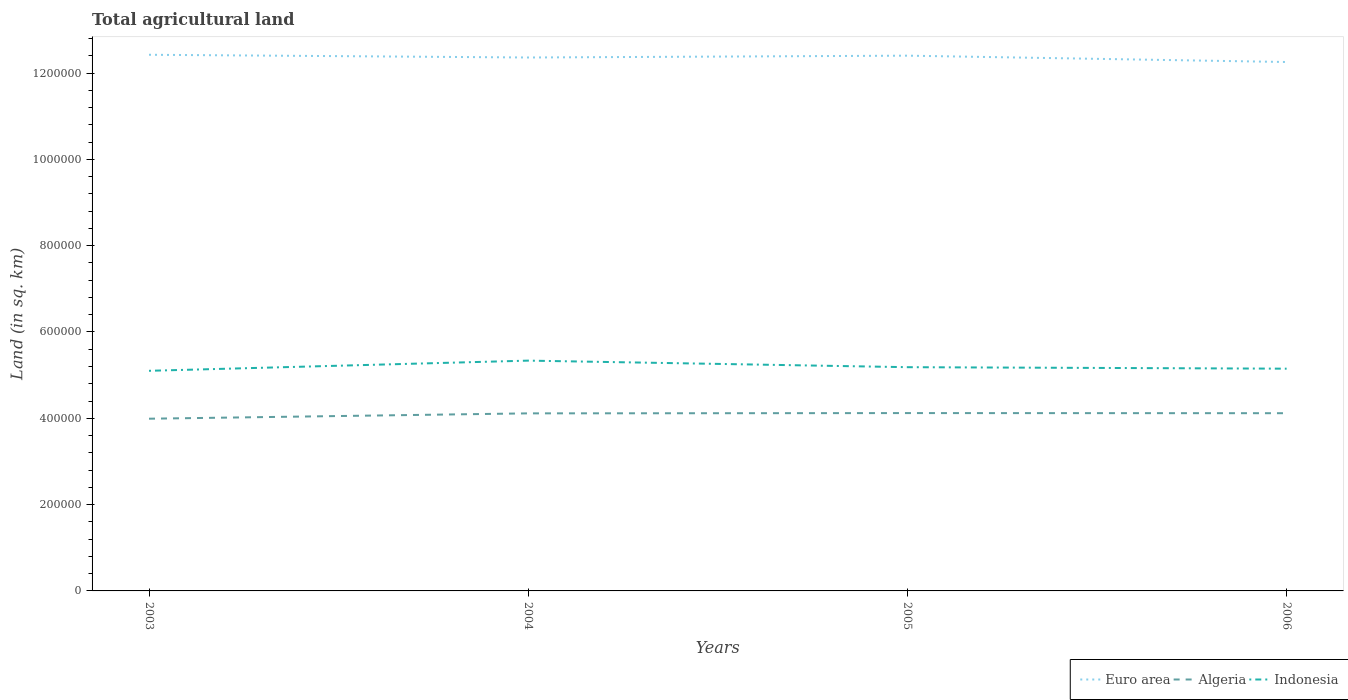Does the line corresponding to Algeria intersect with the line corresponding to Euro area?
Your answer should be very brief. No. Across all years, what is the maximum total agricultural land in Algeria?
Your response must be concise. 3.99e+05. What is the total total agricultural land in Euro area in the graph?
Provide a short and direct response. -4246.5. What is the difference between the highest and the second highest total agricultural land in Euro area?
Give a very brief answer. 1.68e+04. What is the difference between the highest and the lowest total agricultural land in Indonesia?
Offer a terse response. 1. How many years are there in the graph?
Keep it short and to the point. 4. What is the difference between two consecutive major ticks on the Y-axis?
Your answer should be compact. 2.00e+05. Does the graph contain grids?
Provide a succinct answer. No. Where does the legend appear in the graph?
Keep it short and to the point. Bottom right. What is the title of the graph?
Offer a very short reply. Total agricultural land. Does "Israel" appear as one of the legend labels in the graph?
Ensure brevity in your answer.  No. What is the label or title of the Y-axis?
Your answer should be very brief. Land (in sq. km). What is the Land (in sq. km) of Euro area in 2003?
Ensure brevity in your answer.  1.24e+06. What is the Land (in sq. km) in Algeria in 2003?
Your answer should be very brief. 3.99e+05. What is the Land (in sq. km) in Indonesia in 2003?
Provide a succinct answer. 5.10e+05. What is the Land (in sq. km) of Euro area in 2004?
Your response must be concise. 1.24e+06. What is the Land (in sq. km) of Algeria in 2004?
Your answer should be very brief. 4.11e+05. What is the Land (in sq. km) of Indonesia in 2004?
Offer a very short reply. 5.34e+05. What is the Land (in sq. km) in Euro area in 2005?
Offer a very short reply. 1.24e+06. What is the Land (in sq. km) in Algeria in 2005?
Offer a terse response. 4.12e+05. What is the Land (in sq. km) of Indonesia in 2005?
Offer a terse response. 5.18e+05. What is the Land (in sq. km) of Euro area in 2006?
Offer a very short reply. 1.23e+06. What is the Land (in sq. km) in Algeria in 2006?
Provide a succinct answer. 4.12e+05. What is the Land (in sq. km) in Indonesia in 2006?
Provide a succinct answer. 5.15e+05. Across all years, what is the maximum Land (in sq. km) in Euro area?
Provide a succinct answer. 1.24e+06. Across all years, what is the maximum Land (in sq. km) of Algeria?
Offer a terse response. 4.12e+05. Across all years, what is the maximum Land (in sq. km) in Indonesia?
Offer a very short reply. 5.34e+05. Across all years, what is the minimum Land (in sq. km) in Euro area?
Give a very brief answer. 1.23e+06. Across all years, what is the minimum Land (in sq. km) in Algeria?
Provide a succinct answer. 3.99e+05. Across all years, what is the minimum Land (in sq. km) of Indonesia?
Give a very brief answer. 5.10e+05. What is the total Land (in sq. km) in Euro area in the graph?
Provide a succinct answer. 4.94e+06. What is the total Land (in sq. km) of Algeria in the graph?
Your response must be concise. 1.63e+06. What is the total Land (in sq. km) of Indonesia in the graph?
Make the answer very short. 2.08e+06. What is the difference between the Land (in sq. km) of Euro area in 2003 and that in 2004?
Provide a short and direct response. 6314.3. What is the difference between the Land (in sq. km) in Algeria in 2003 and that in 2004?
Offer a terse response. -1.24e+04. What is the difference between the Land (in sq. km) of Indonesia in 2003 and that in 2004?
Provide a short and direct response. -2.36e+04. What is the difference between the Land (in sq. km) in Euro area in 2003 and that in 2005?
Your answer should be very brief. 2067.8. What is the difference between the Land (in sq. km) in Algeria in 2003 and that in 2005?
Provide a short and direct response. -1.31e+04. What is the difference between the Land (in sq. km) of Indonesia in 2003 and that in 2005?
Offer a terse response. -8400. What is the difference between the Land (in sq. km) in Euro area in 2003 and that in 2006?
Your answer should be compact. 1.68e+04. What is the difference between the Land (in sq. km) in Algeria in 2003 and that in 2006?
Your answer should be very brief. -1.28e+04. What is the difference between the Land (in sq. km) in Indonesia in 2003 and that in 2006?
Provide a succinct answer. -4940. What is the difference between the Land (in sq. km) in Euro area in 2004 and that in 2005?
Keep it short and to the point. -4246.5. What is the difference between the Land (in sq. km) in Algeria in 2004 and that in 2005?
Make the answer very short. -660. What is the difference between the Land (in sq. km) in Indonesia in 2004 and that in 2005?
Provide a short and direct response. 1.52e+04. What is the difference between the Land (in sq. km) of Euro area in 2004 and that in 2006?
Offer a terse response. 1.05e+04. What is the difference between the Land (in sq. km) of Algeria in 2004 and that in 2006?
Your answer should be compact. -360. What is the difference between the Land (in sq. km) of Indonesia in 2004 and that in 2006?
Your answer should be compact. 1.87e+04. What is the difference between the Land (in sq. km) in Euro area in 2005 and that in 2006?
Provide a short and direct response. 1.47e+04. What is the difference between the Land (in sq. km) in Algeria in 2005 and that in 2006?
Ensure brevity in your answer.  300. What is the difference between the Land (in sq. km) in Indonesia in 2005 and that in 2006?
Your answer should be compact. 3460. What is the difference between the Land (in sq. km) in Euro area in 2003 and the Land (in sq. km) in Algeria in 2004?
Offer a terse response. 8.31e+05. What is the difference between the Land (in sq. km) in Euro area in 2003 and the Land (in sq. km) in Indonesia in 2004?
Make the answer very short. 7.09e+05. What is the difference between the Land (in sq. km) of Algeria in 2003 and the Land (in sq. km) of Indonesia in 2004?
Ensure brevity in your answer.  -1.35e+05. What is the difference between the Land (in sq. km) in Euro area in 2003 and the Land (in sq. km) in Algeria in 2005?
Provide a succinct answer. 8.30e+05. What is the difference between the Land (in sq. km) of Euro area in 2003 and the Land (in sq. km) of Indonesia in 2005?
Your answer should be very brief. 7.24e+05. What is the difference between the Land (in sq. km) in Algeria in 2003 and the Land (in sq. km) in Indonesia in 2005?
Offer a terse response. -1.19e+05. What is the difference between the Land (in sq. km) in Euro area in 2003 and the Land (in sq. km) in Algeria in 2006?
Offer a terse response. 8.31e+05. What is the difference between the Land (in sq. km) in Euro area in 2003 and the Land (in sq. km) in Indonesia in 2006?
Make the answer very short. 7.27e+05. What is the difference between the Land (in sq. km) of Algeria in 2003 and the Land (in sq. km) of Indonesia in 2006?
Give a very brief answer. -1.16e+05. What is the difference between the Land (in sq. km) in Euro area in 2004 and the Land (in sq. km) in Algeria in 2005?
Your response must be concise. 8.24e+05. What is the difference between the Land (in sq. km) of Euro area in 2004 and the Land (in sq. km) of Indonesia in 2005?
Offer a very short reply. 7.18e+05. What is the difference between the Land (in sq. km) in Algeria in 2004 and the Land (in sq. km) in Indonesia in 2005?
Give a very brief answer. -1.07e+05. What is the difference between the Land (in sq. km) of Euro area in 2004 and the Land (in sq. km) of Algeria in 2006?
Give a very brief answer. 8.24e+05. What is the difference between the Land (in sq. km) in Euro area in 2004 and the Land (in sq. km) in Indonesia in 2006?
Keep it short and to the point. 7.21e+05. What is the difference between the Land (in sq. km) in Algeria in 2004 and the Land (in sq. km) in Indonesia in 2006?
Your answer should be compact. -1.04e+05. What is the difference between the Land (in sq. km) of Euro area in 2005 and the Land (in sq. km) of Algeria in 2006?
Keep it short and to the point. 8.29e+05. What is the difference between the Land (in sq. km) in Euro area in 2005 and the Land (in sq. km) in Indonesia in 2006?
Keep it short and to the point. 7.25e+05. What is the difference between the Land (in sq. km) in Algeria in 2005 and the Land (in sq. km) in Indonesia in 2006?
Your answer should be very brief. -1.03e+05. What is the average Land (in sq. km) of Euro area per year?
Give a very brief answer. 1.24e+06. What is the average Land (in sq. km) in Algeria per year?
Ensure brevity in your answer.  4.09e+05. What is the average Land (in sq. km) in Indonesia per year?
Make the answer very short. 5.19e+05. In the year 2003, what is the difference between the Land (in sq. km) of Euro area and Land (in sq. km) of Algeria?
Keep it short and to the point. 8.43e+05. In the year 2003, what is the difference between the Land (in sq. km) of Euro area and Land (in sq. km) of Indonesia?
Offer a terse response. 7.32e+05. In the year 2003, what is the difference between the Land (in sq. km) in Algeria and Land (in sq. km) in Indonesia?
Your answer should be compact. -1.11e+05. In the year 2004, what is the difference between the Land (in sq. km) of Euro area and Land (in sq. km) of Algeria?
Keep it short and to the point. 8.25e+05. In the year 2004, what is the difference between the Land (in sq. km) in Euro area and Land (in sq. km) in Indonesia?
Your response must be concise. 7.02e+05. In the year 2004, what is the difference between the Land (in sq. km) of Algeria and Land (in sq. km) of Indonesia?
Your answer should be compact. -1.22e+05. In the year 2005, what is the difference between the Land (in sq. km) in Euro area and Land (in sq. km) in Algeria?
Make the answer very short. 8.28e+05. In the year 2005, what is the difference between the Land (in sq. km) in Euro area and Land (in sq. km) in Indonesia?
Provide a short and direct response. 7.22e+05. In the year 2005, what is the difference between the Land (in sq. km) in Algeria and Land (in sq. km) in Indonesia?
Your answer should be compact. -1.06e+05. In the year 2006, what is the difference between the Land (in sq. km) in Euro area and Land (in sq. km) in Algeria?
Keep it short and to the point. 8.14e+05. In the year 2006, what is the difference between the Land (in sq. km) of Euro area and Land (in sq. km) of Indonesia?
Ensure brevity in your answer.  7.11e+05. In the year 2006, what is the difference between the Land (in sq. km) in Algeria and Land (in sq. km) in Indonesia?
Your response must be concise. -1.03e+05. What is the ratio of the Land (in sq. km) of Euro area in 2003 to that in 2004?
Your response must be concise. 1.01. What is the ratio of the Land (in sq. km) in Algeria in 2003 to that in 2004?
Your answer should be very brief. 0.97. What is the ratio of the Land (in sq. km) in Indonesia in 2003 to that in 2004?
Your answer should be compact. 0.96. What is the ratio of the Land (in sq. km) of Euro area in 2003 to that in 2005?
Provide a short and direct response. 1. What is the ratio of the Land (in sq. km) of Algeria in 2003 to that in 2005?
Your response must be concise. 0.97. What is the ratio of the Land (in sq. km) of Indonesia in 2003 to that in 2005?
Ensure brevity in your answer.  0.98. What is the ratio of the Land (in sq. km) of Euro area in 2003 to that in 2006?
Offer a terse response. 1.01. What is the ratio of the Land (in sq. km) in Indonesia in 2003 to that in 2006?
Provide a short and direct response. 0.99. What is the ratio of the Land (in sq. km) in Euro area in 2004 to that in 2005?
Offer a terse response. 1. What is the ratio of the Land (in sq. km) of Algeria in 2004 to that in 2005?
Make the answer very short. 1. What is the ratio of the Land (in sq. km) in Indonesia in 2004 to that in 2005?
Provide a short and direct response. 1.03. What is the ratio of the Land (in sq. km) in Euro area in 2004 to that in 2006?
Give a very brief answer. 1.01. What is the ratio of the Land (in sq. km) in Algeria in 2004 to that in 2006?
Offer a terse response. 1. What is the ratio of the Land (in sq. km) of Indonesia in 2004 to that in 2006?
Provide a short and direct response. 1.04. What is the ratio of the Land (in sq. km) of Euro area in 2005 to that in 2006?
Ensure brevity in your answer.  1.01. What is the ratio of the Land (in sq. km) of Algeria in 2005 to that in 2006?
Your response must be concise. 1. What is the ratio of the Land (in sq. km) of Indonesia in 2005 to that in 2006?
Your response must be concise. 1.01. What is the difference between the highest and the second highest Land (in sq. km) of Euro area?
Ensure brevity in your answer.  2067.8. What is the difference between the highest and the second highest Land (in sq. km) of Algeria?
Make the answer very short. 300. What is the difference between the highest and the second highest Land (in sq. km) in Indonesia?
Ensure brevity in your answer.  1.52e+04. What is the difference between the highest and the lowest Land (in sq. km) of Euro area?
Keep it short and to the point. 1.68e+04. What is the difference between the highest and the lowest Land (in sq. km) of Algeria?
Your answer should be very brief. 1.31e+04. What is the difference between the highest and the lowest Land (in sq. km) in Indonesia?
Your answer should be very brief. 2.36e+04. 